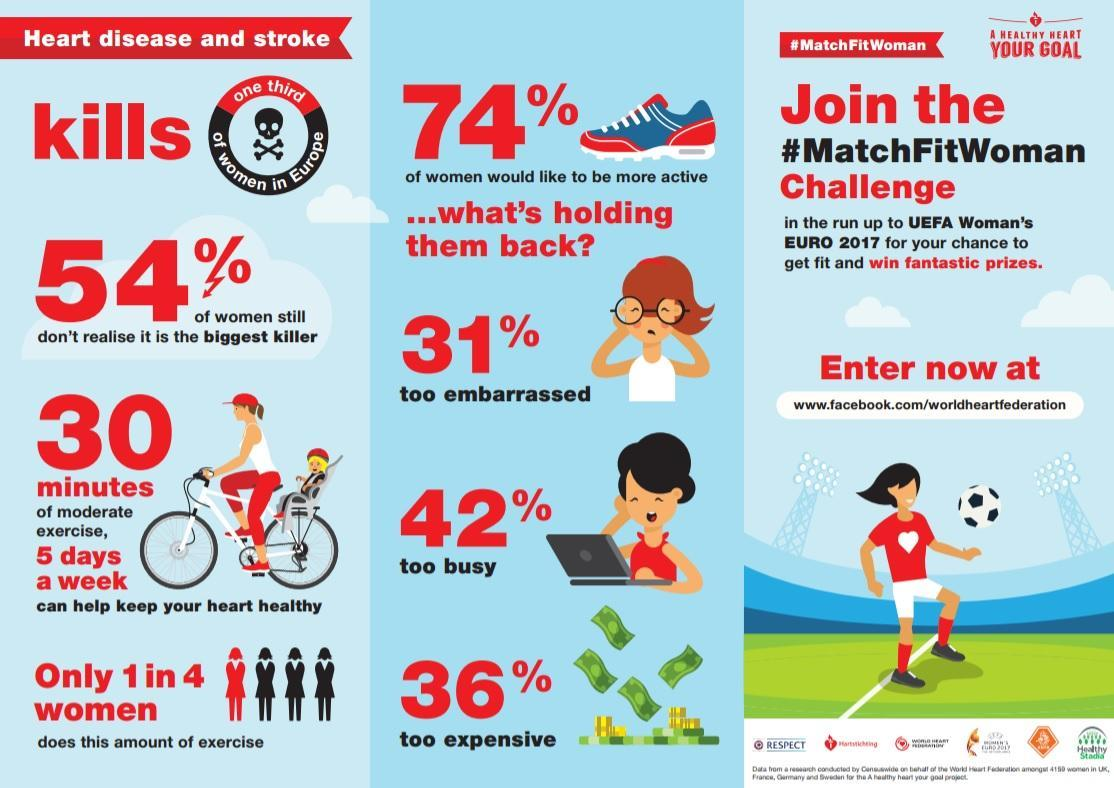What is the hashtag mentioned?
Answer the question with a short phrase. #MatchFitWoman What proportion of women do not do 30 minutes of moderate exercise 5 days a week? 3 in 4 women What is the top reason holding women back from being more active? too busy 